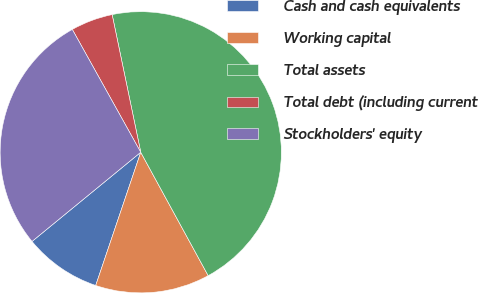<chart> <loc_0><loc_0><loc_500><loc_500><pie_chart><fcel>Cash and cash equivalents<fcel>Working capital<fcel>Total assets<fcel>Total debt (including current<fcel>Stockholders' equity<nl><fcel>8.88%<fcel>13.15%<fcel>45.3%<fcel>4.83%<fcel>27.84%<nl></chart> 